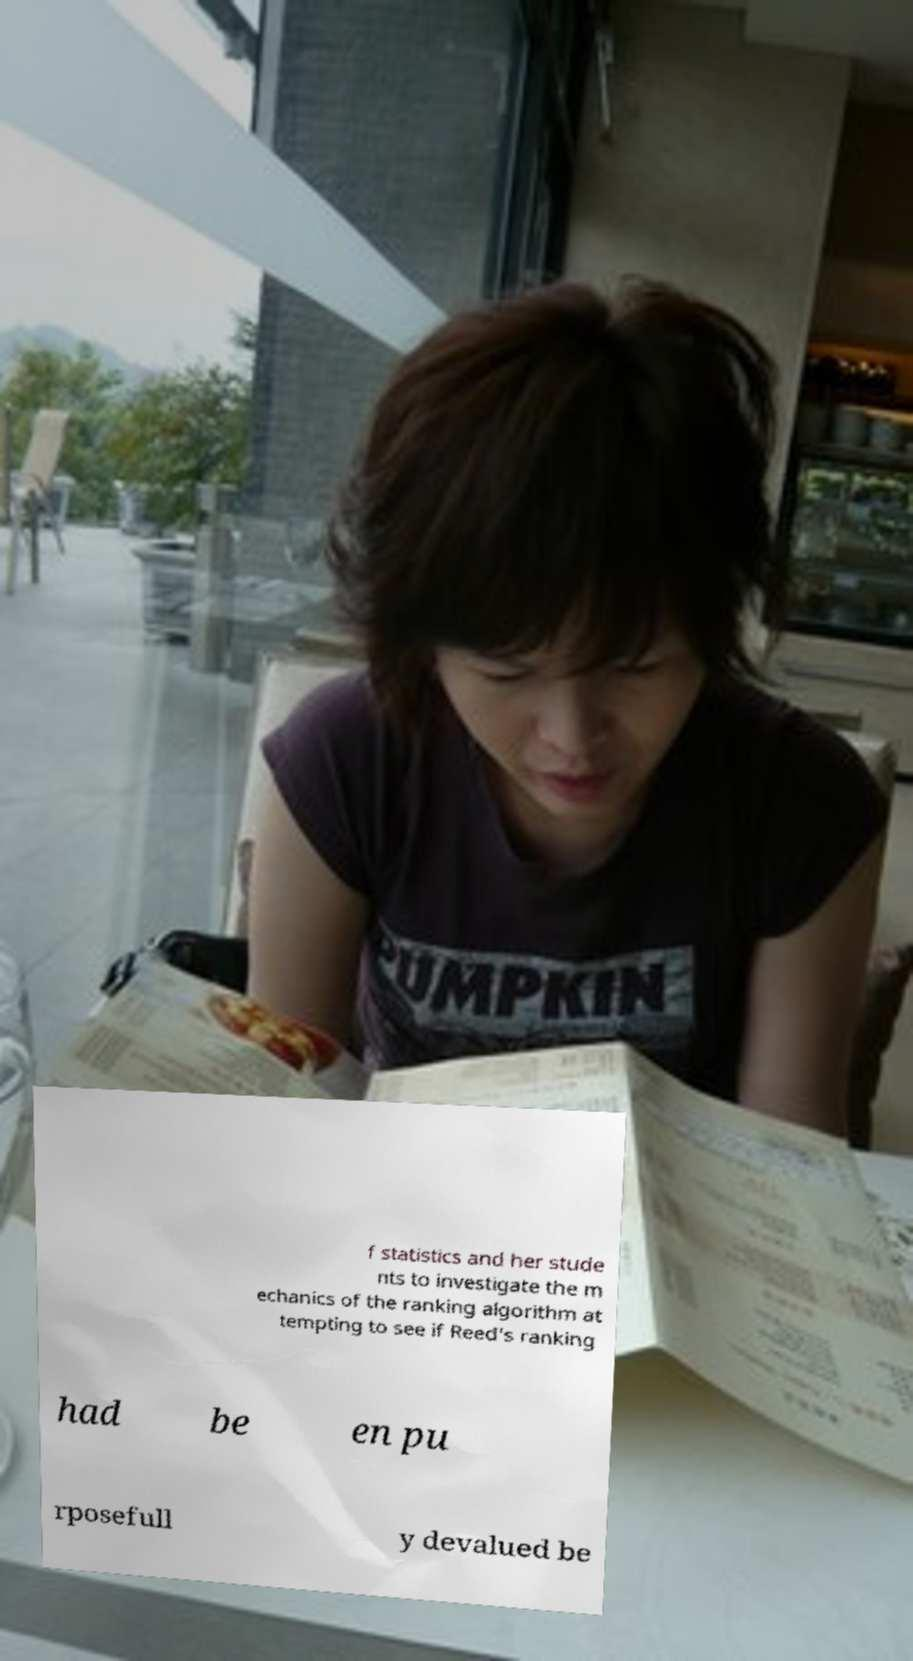Could you extract and type out the text from this image? f statistics and her stude nts to investigate the m echanics of the ranking algorithm at tempting to see if Reed's ranking had be en pu rposefull y devalued be 